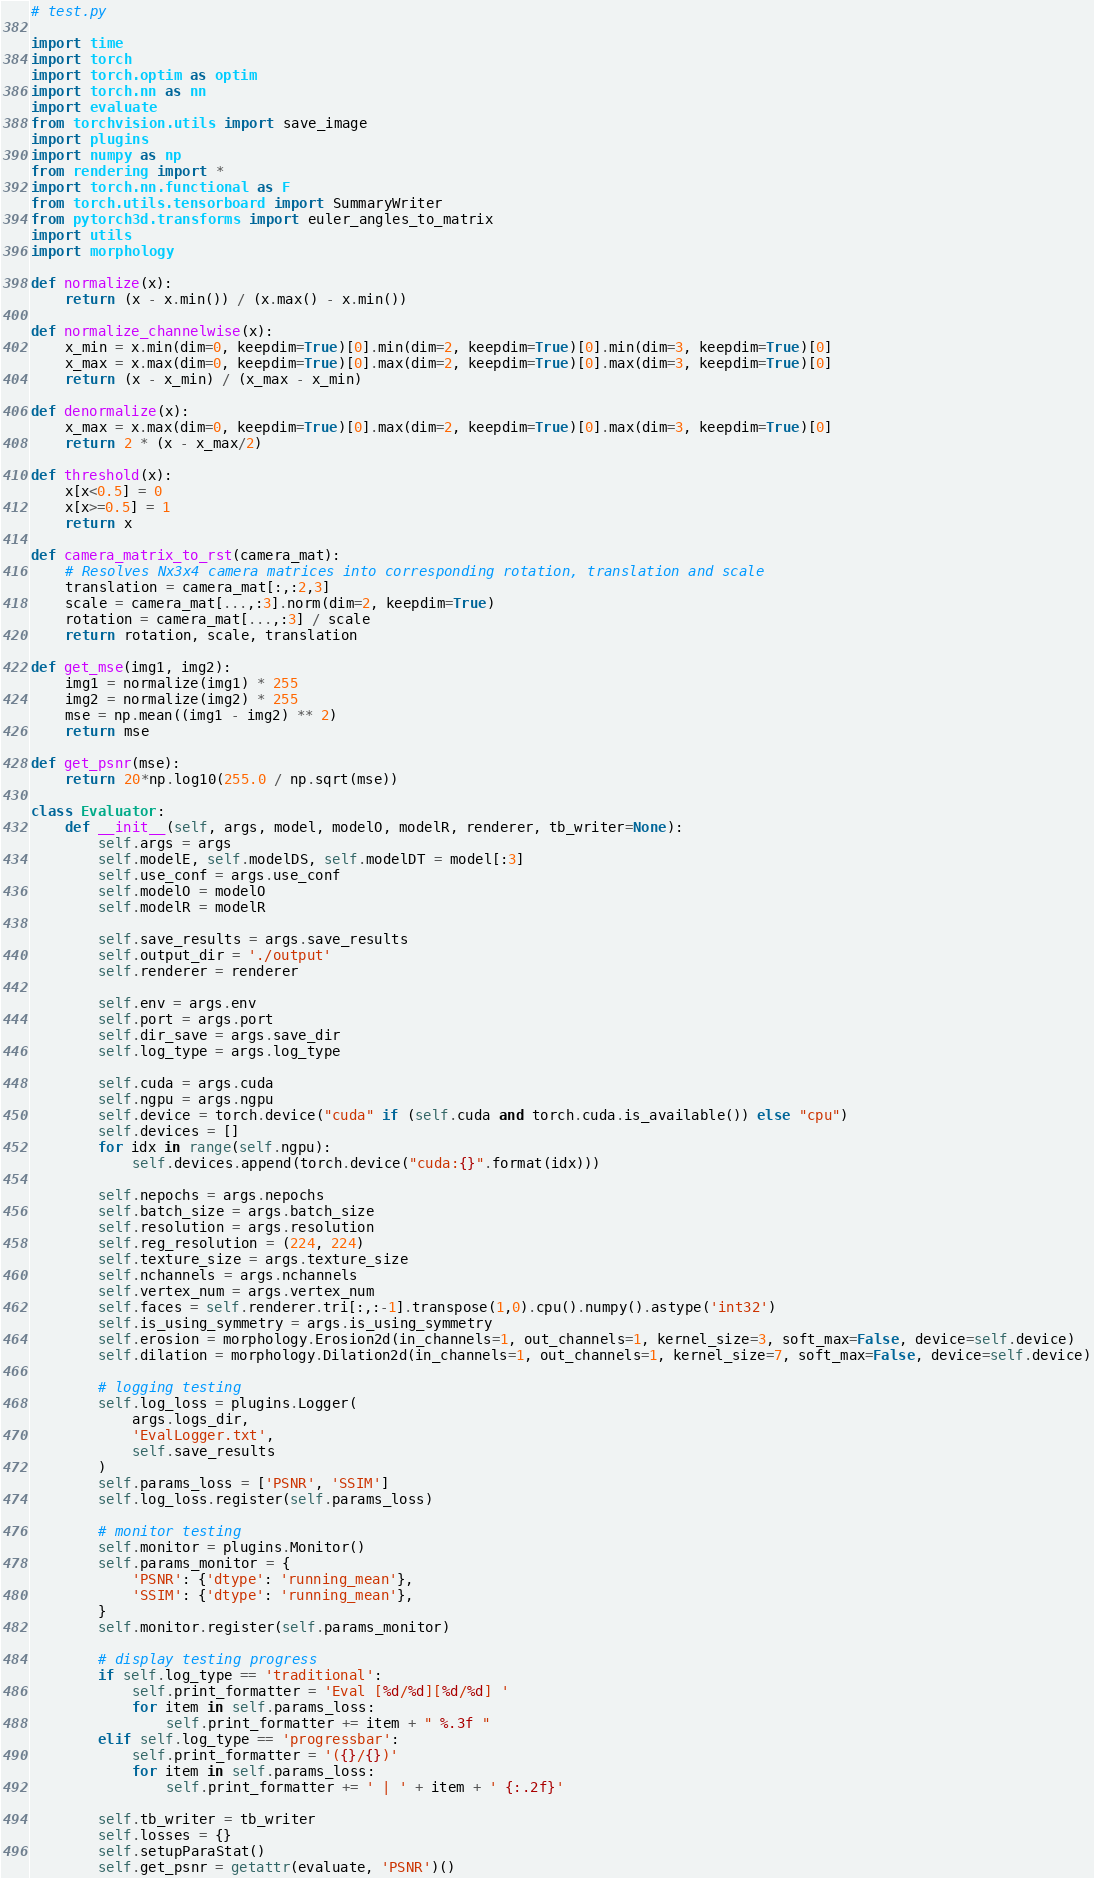Convert code to text. <code><loc_0><loc_0><loc_500><loc_500><_Python_># test.py

import time
import torch
import torch.optim as optim
import torch.nn as nn
import evaluate
from torchvision.utils import save_image
import plugins
import numpy as np
from rendering import *
import torch.nn.functional as F
from torch.utils.tensorboard import SummaryWriter
from pytorch3d.transforms import euler_angles_to_matrix
import utils
import morphology

def normalize(x):
    return (x - x.min()) / (x.max() - x.min())

def normalize_channelwise(x):
    x_min = x.min(dim=0, keepdim=True)[0].min(dim=2, keepdim=True)[0].min(dim=3, keepdim=True)[0]
    x_max = x.max(dim=0, keepdim=True)[0].max(dim=2, keepdim=True)[0].max(dim=3, keepdim=True)[0]
    return (x - x_min) / (x_max - x_min)

def denormalize(x):
    x_max = x.max(dim=0, keepdim=True)[0].max(dim=2, keepdim=True)[0].max(dim=3, keepdim=True)[0]
    return 2 * (x - x_max/2)

def threshold(x):
    x[x<0.5] = 0
    x[x>=0.5] = 1
    return x

def camera_matrix_to_rst(camera_mat):
    # Resolves Nx3x4 camera matrices into corresponding rotation, translation and scale
    translation = camera_mat[:,:2,3]
    scale = camera_mat[...,:3].norm(dim=2, keepdim=True)
    rotation = camera_mat[...,:3] / scale
    return rotation, scale, translation

def get_mse(img1, img2):
    img1 = normalize(img1) * 255
    img2 = normalize(img2) * 255
    mse = np.mean((img1 - img2) ** 2)
    return mse

def get_psnr(mse):
    return 20*np.log10(255.0 / np.sqrt(mse))

class Evaluator:
    def __init__(self, args, model, modelO, modelR, renderer, tb_writer=None):
        self.args = args
        self.modelE, self.modelDS, self.modelDT = model[:3]
        self.use_conf = args.use_conf
        self.modelO = modelO
        self.modelR = modelR

        self.save_results = args.save_results
        self.output_dir = './output'
        self.renderer = renderer

        self.env = args.env
        self.port = args.port
        self.dir_save = args.save_dir
        self.log_type = args.log_type

        self.cuda = args.cuda
        self.ngpu = args.ngpu
        self.device = torch.device("cuda" if (self.cuda and torch.cuda.is_available()) else "cpu")
        self.devices = []
        for idx in range(self.ngpu):
            self.devices.append(torch.device("cuda:{}".format(idx)))

        self.nepochs = args.nepochs
        self.batch_size = args.batch_size
        self.resolution = args.resolution
        self.reg_resolution = (224, 224)
        self.texture_size = args.texture_size
        self.nchannels = args.nchannels
        self.vertex_num = args.vertex_num
        self.faces = self.renderer.tri[:,:-1].transpose(1,0).cpu().numpy().astype('int32')
        self.is_using_symmetry = args.is_using_symmetry
        self.erosion = morphology.Erosion2d(in_channels=1, out_channels=1, kernel_size=3, soft_max=False, device=self.device)
        self.dilation = morphology.Dilation2d(in_channels=1, out_channels=1, kernel_size=7, soft_max=False, device=self.device)

        # logging testing
        self.log_loss = plugins.Logger(
            args.logs_dir,
            'EvalLogger.txt',
            self.save_results
        )
        self.params_loss = ['PSNR', 'SSIM']
        self.log_loss.register(self.params_loss)

        # monitor testing
        self.monitor = plugins.Monitor()
        self.params_monitor = {
            'PSNR': {'dtype': 'running_mean'},
            'SSIM': {'dtype': 'running_mean'},
        }
        self.monitor.register(self.params_monitor)

        # display testing progress
        if self.log_type == 'traditional':
            self.print_formatter = 'Eval [%d/%d][%d/%d] '
            for item in self.params_loss:
                self.print_formatter += item + " %.3f "
        elif self.log_type == 'progressbar':
            self.print_formatter = '({}/{})'
            for item in self.params_loss:
                self.print_formatter += ' | ' + item + ' {:.2f}'

        self.tb_writer = tb_writer
        self.losses = {}
        self.setupParaStat()
        self.get_psnr = getattr(evaluate, 'PSNR')()</code> 